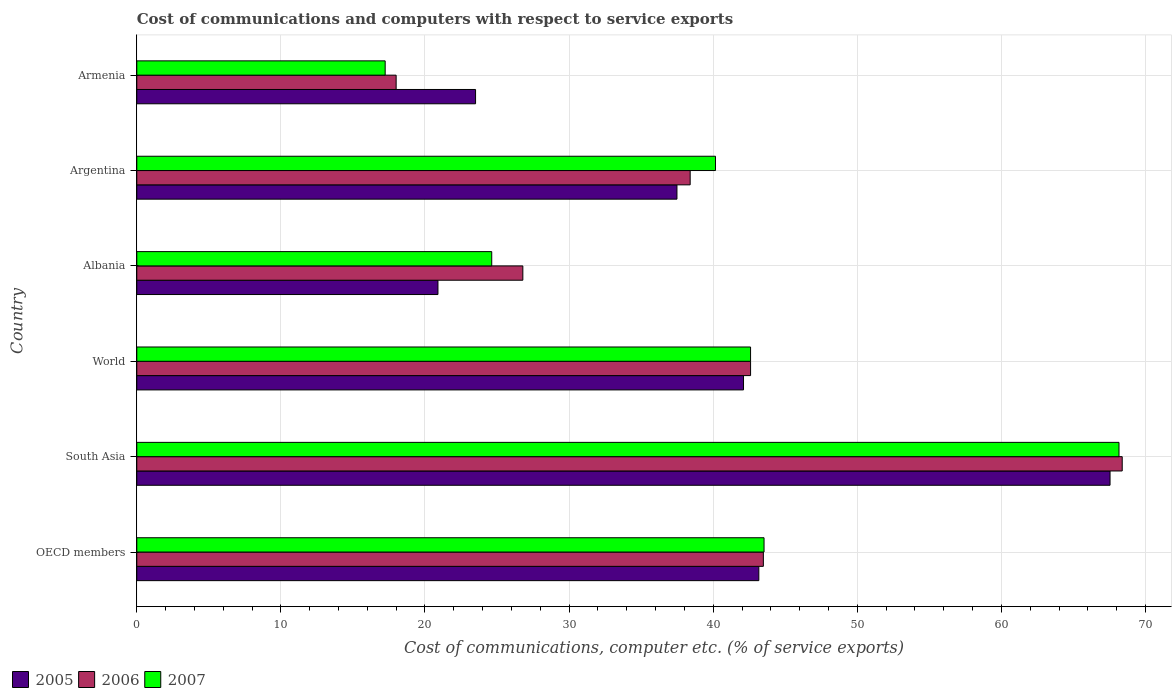How many different coloured bars are there?
Keep it short and to the point. 3. Are the number of bars on each tick of the Y-axis equal?
Ensure brevity in your answer.  Yes. What is the label of the 1st group of bars from the top?
Make the answer very short. Armenia. What is the cost of communications and computers in 2006 in Albania?
Offer a terse response. 26.79. Across all countries, what is the maximum cost of communications and computers in 2006?
Provide a succinct answer. 68.39. Across all countries, what is the minimum cost of communications and computers in 2007?
Ensure brevity in your answer.  17.24. In which country was the cost of communications and computers in 2006 minimum?
Provide a short and direct response. Armenia. What is the total cost of communications and computers in 2006 in the graph?
Your answer should be compact. 237.65. What is the difference between the cost of communications and computers in 2005 in South Asia and that in World?
Make the answer very short. 25.44. What is the difference between the cost of communications and computers in 2005 in South Asia and the cost of communications and computers in 2007 in Armenia?
Offer a very short reply. 50.3. What is the average cost of communications and computers in 2007 per country?
Keep it short and to the point. 39.39. What is the difference between the cost of communications and computers in 2006 and cost of communications and computers in 2005 in Argentina?
Provide a short and direct response. 0.92. In how many countries, is the cost of communications and computers in 2007 greater than 32 %?
Ensure brevity in your answer.  4. What is the ratio of the cost of communications and computers in 2007 in Albania to that in World?
Your answer should be very brief. 0.58. Is the difference between the cost of communications and computers in 2006 in South Asia and World greater than the difference between the cost of communications and computers in 2005 in South Asia and World?
Your answer should be very brief. Yes. What is the difference between the highest and the second highest cost of communications and computers in 2006?
Keep it short and to the point. 24.9. What is the difference between the highest and the lowest cost of communications and computers in 2006?
Offer a terse response. 50.39. In how many countries, is the cost of communications and computers in 2007 greater than the average cost of communications and computers in 2007 taken over all countries?
Give a very brief answer. 4. Is the sum of the cost of communications and computers in 2006 in OECD members and South Asia greater than the maximum cost of communications and computers in 2007 across all countries?
Give a very brief answer. Yes. What does the 1st bar from the bottom in Armenia represents?
Provide a succinct answer. 2005. Are all the bars in the graph horizontal?
Your answer should be very brief. Yes. Are the values on the major ticks of X-axis written in scientific E-notation?
Ensure brevity in your answer.  No. Where does the legend appear in the graph?
Make the answer very short. Bottom left. How many legend labels are there?
Provide a succinct answer. 3. How are the legend labels stacked?
Your answer should be very brief. Horizontal. What is the title of the graph?
Your response must be concise. Cost of communications and computers with respect to service exports. Does "1979" appear as one of the legend labels in the graph?
Your answer should be very brief. No. What is the label or title of the X-axis?
Offer a very short reply. Cost of communications, computer etc. (% of service exports). What is the Cost of communications, computer etc. (% of service exports) in 2005 in OECD members?
Your answer should be compact. 43.17. What is the Cost of communications, computer etc. (% of service exports) in 2006 in OECD members?
Offer a very short reply. 43.48. What is the Cost of communications, computer etc. (% of service exports) in 2007 in OECD members?
Offer a very short reply. 43.53. What is the Cost of communications, computer etc. (% of service exports) of 2005 in South Asia?
Make the answer very short. 67.54. What is the Cost of communications, computer etc. (% of service exports) in 2006 in South Asia?
Ensure brevity in your answer.  68.39. What is the Cost of communications, computer etc. (% of service exports) of 2007 in South Asia?
Your response must be concise. 68.16. What is the Cost of communications, computer etc. (% of service exports) in 2005 in World?
Make the answer very short. 42.1. What is the Cost of communications, computer etc. (% of service exports) of 2006 in World?
Offer a very short reply. 42.59. What is the Cost of communications, computer etc. (% of service exports) of 2007 in World?
Your answer should be very brief. 42.59. What is the Cost of communications, computer etc. (% of service exports) of 2005 in Albania?
Ensure brevity in your answer.  20.9. What is the Cost of communications, computer etc. (% of service exports) of 2006 in Albania?
Offer a very short reply. 26.79. What is the Cost of communications, computer etc. (% of service exports) in 2007 in Albania?
Your answer should be very brief. 24.63. What is the Cost of communications, computer etc. (% of service exports) in 2005 in Argentina?
Make the answer very short. 37.49. What is the Cost of communications, computer etc. (% of service exports) in 2006 in Argentina?
Your response must be concise. 38.4. What is the Cost of communications, computer etc. (% of service exports) of 2007 in Argentina?
Keep it short and to the point. 40.16. What is the Cost of communications, computer etc. (% of service exports) in 2005 in Armenia?
Offer a terse response. 23.51. What is the Cost of communications, computer etc. (% of service exports) in 2006 in Armenia?
Ensure brevity in your answer.  18. What is the Cost of communications, computer etc. (% of service exports) of 2007 in Armenia?
Your answer should be very brief. 17.24. Across all countries, what is the maximum Cost of communications, computer etc. (% of service exports) of 2005?
Give a very brief answer. 67.54. Across all countries, what is the maximum Cost of communications, computer etc. (% of service exports) of 2006?
Ensure brevity in your answer.  68.39. Across all countries, what is the maximum Cost of communications, computer etc. (% of service exports) in 2007?
Offer a very short reply. 68.16. Across all countries, what is the minimum Cost of communications, computer etc. (% of service exports) of 2005?
Give a very brief answer. 20.9. Across all countries, what is the minimum Cost of communications, computer etc. (% of service exports) of 2006?
Offer a very short reply. 18. Across all countries, what is the minimum Cost of communications, computer etc. (% of service exports) in 2007?
Your answer should be compact. 17.24. What is the total Cost of communications, computer etc. (% of service exports) of 2005 in the graph?
Your response must be concise. 234.71. What is the total Cost of communications, computer etc. (% of service exports) in 2006 in the graph?
Ensure brevity in your answer.  237.65. What is the total Cost of communications, computer etc. (% of service exports) of 2007 in the graph?
Your answer should be compact. 236.31. What is the difference between the Cost of communications, computer etc. (% of service exports) in 2005 in OECD members and that in South Asia?
Your answer should be very brief. -24.37. What is the difference between the Cost of communications, computer etc. (% of service exports) of 2006 in OECD members and that in South Asia?
Keep it short and to the point. -24.9. What is the difference between the Cost of communications, computer etc. (% of service exports) in 2007 in OECD members and that in South Asia?
Your answer should be very brief. -24.63. What is the difference between the Cost of communications, computer etc. (% of service exports) of 2005 in OECD members and that in World?
Offer a very short reply. 1.06. What is the difference between the Cost of communications, computer etc. (% of service exports) of 2006 in OECD members and that in World?
Your answer should be compact. 0.89. What is the difference between the Cost of communications, computer etc. (% of service exports) in 2007 in OECD members and that in World?
Provide a succinct answer. 0.94. What is the difference between the Cost of communications, computer etc. (% of service exports) in 2005 in OECD members and that in Albania?
Offer a very short reply. 22.27. What is the difference between the Cost of communications, computer etc. (% of service exports) in 2006 in OECD members and that in Albania?
Ensure brevity in your answer.  16.69. What is the difference between the Cost of communications, computer etc. (% of service exports) of 2007 in OECD members and that in Albania?
Your response must be concise. 18.9. What is the difference between the Cost of communications, computer etc. (% of service exports) of 2005 in OECD members and that in Argentina?
Make the answer very short. 5.68. What is the difference between the Cost of communications, computer etc. (% of service exports) in 2006 in OECD members and that in Argentina?
Your answer should be very brief. 5.08. What is the difference between the Cost of communications, computer etc. (% of service exports) in 2007 in OECD members and that in Argentina?
Offer a very short reply. 3.37. What is the difference between the Cost of communications, computer etc. (% of service exports) of 2005 in OECD members and that in Armenia?
Ensure brevity in your answer.  19.66. What is the difference between the Cost of communications, computer etc. (% of service exports) in 2006 in OECD members and that in Armenia?
Offer a terse response. 25.48. What is the difference between the Cost of communications, computer etc. (% of service exports) of 2007 in OECD members and that in Armenia?
Provide a short and direct response. 26.29. What is the difference between the Cost of communications, computer etc. (% of service exports) of 2005 in South Asia and that in World?
Your response must be concise. 25.44. What is the difference between the Cost of communications, computer etc. (% of service exports) of 2006 in South Asia and that in World?
Provide a succinct answer. 25.79. What is the difference between the Cost of communications, computer etc. (% of service exports) of 2007 in South Asia and that in World?
Your response must be concise. 25.57. What is the difference between the Cost of communications, computer etc. (% of service exports) of 2005 in South Asia and that in Albania?
Offer a very short reply. 46.64. What is the difference between the Cost of communications, computer etc. (% of service exports) of 2006 in South Asia and that in Albania?
Give a very brief answer. 41.59. What is the difference between the Cost of communications, computer etc. (% of service exports) in 2007 in South Asia and that in Albania?
Give a very brief answer. 43.53. What is the difference between the Cost of communications, computer etc. (% of service exports) of 2005 in South Asia and that in Argentina?
Make the answer very short. 30.06. What is the difference between the Cost of communications, computer etc. (% of service exports) of 2006 in South Asia and that in Argentina?
Ensure brevity in your answer.  29.98. What is the difference between the Cost of communications, computer etc. (% of service exports) of 2007 in South Asia and that in Argentina?
Make the answer very short. 28. What is the difference between the Cost of communications, computer etc. (% of service exports) of 2005 in South Asia and that in Armenia?
Your answer should be compact. 44.03. What is the difference between the Cost of communications, computer etc. (% of service exports) of 2006 in South Asia and that in Armenia?
Your answer should be compact. 50.39. What is the difference between the Cost of communications, computer etc. (% of service exports) in 2007 in South Asia and that in Armenia?
Provide a succinct answer. 50.92. What is the difference between the Cost of communications, computer etc. (% of service exports) in 2005 in World and that in Albania?
Your answer should be compact. 21.2. What is the difference between the Cost of communications, computer etc. (% of service exports) in 2006 in World and that in Albania?
Your answer should be compact. 15.8. What is the difference between the Cost of communications, computer etc. (% of service exports) of 2007 in World and that in Albania?
Make the answer very short. 17.96. What is the difference between the Cost of communications, computer etc. (% of service exports) of 2005 in World and that in Argentina?
Your answer should be very brief. 4.62. What is the difference between the Cost of communications, computer etc. (% of service exports) in 2006 in World and that in Argentina?
Make the answer very short. 4.19. What is the difference between the Cost of communications, computer etc. (% of service exports) of 2007 in World and that in Argentina?
Make the answer very short. 2.43. What is the difference between the Cost of communications, computer etc. (% of service exports) of 2005 in World and that in Armenia?
Give a very brief answer. 18.59. What is the difference between the Cost of communications, computer etc. (% of service exports) of 2006 in World and that in Armenia?
Provide a short and direct response. 24.6. What is the difference between the Cost of communications, computer etc. (% of service exports) in 2007 in World and that in Armenia?
Offer a terse response. 25.36. What is the difference between the Cost of communications, computer etc. (% of service exports) of 2005 in Albania and that in Argentina?
Offer a very short reply. -16.59. What is the difference between the Cost of communications, computer etc. (% of service exports) of 2006 in Albania and that in Argentina?
Make the answer very short. -11.61. What is the difference between the Cost of communications, computer etc. (% of service exports) in 2007 in Albania and that in Argentina?
Keep it short and to the point. -15.53. What is the difference between the Cost of communications, computer etc. (% of service exports) in 2005 in Albania and that in Armenia?
Offer a terse response. -2.61. What is the difference between the Cost of communications, computer etc. (% of service exports) in 2006 in Albania and that in Armenia?
Offer a very short reply. 8.79. What is the difference between the Cost of communications, computer etc. (% of service exports) in 2007 in Albania and that in Armenia?
Provide a succinct answer. 7.39. What is the difference between the Cost of communications, computer etc. (% of service exports) of 2005 in Argentina and that in Armenia?
Offer a terse response. 13.98. What is the difference between the Cost of communications, computer etc. (% of service exports) in 2006 in Argentina and that in Armenia?
Your response must be concise. 20.4. What is the difference between the Cost of communications, computer etc. (% of service exports) of 2007 in Argentina and that in Armenia?
Make the answer very short. 22.92. What is the difference between the Cost of communications, computer etc. (% of service exports) of 2005 in OECD members and the Cost of communications, computer etc. (% of service exports) of 2006 in South Asia?
Your response must be concise. -25.22. What is the difference between the Cost of communications, computer etc. (% of service exports) of 2005 in OECD members and the Cost of communications, computer etc. (% of service exports) of 2007 in South Asia?
Provide a succinct answer. -24.99. What is the difference between the Cost of communications, computer etc. (% of service exports) in 2006 in OECD members and the Cost of communications, computer etc. (% of service exports) in 2007 in South Asia?
Your answer should be compact. -24.68. What is the difference between the Cost of communications, computer etc. (% of service exports) in 2005 in OECD members and the Cost of communications, computer etc. (% of service exports) in 2006 in World?
Your response must be concise. 0.57. What is the difference between the Cost of communications, computer etc. (% of service exports) in 2005 in OECD members and the Cost of communications, computer etc. (% of service exports) in 2007 in World?
Provide a short and direct response. 0.57. What is the difference between the Cost of communications, computer etc. (% of service exports) of 2006 in OECD members and the Cost of communications, computer etc. (% of service exports) of 2007 in World?
Your answer should be very brief. 0.89. What is the difference between the Cost of communications, computer etc. (% of service exports) of 2005 in OECD members and the Cost of communications, computer etc. (% of service exports) of 2006 in Albania?
Your answer should be compact. 16.38. What is the difference between the Cost of communications, computer etc. (% of service exports) in 2005 in OECD members and the Cost of communications, computer etc. (% of service exports) in 2007 in Albania?
Your answer should be very brief. 18.53. What is the difference between the Cost of communications, computer etc. (% of service exports) of 2006 in OECD members and the Cost of communications, computer etc. (% of service exports) of 2007 in Albania?
Keep it short and to the point. 18.85. What is the difference between the Cost of communications, computer etc. (% of service exports) in 2005 in OECD members and the Cost of communications, computer etc. (% of service exports) in 2006 in Argentina?
Your response must be concise. 4.76. What is the difference between the Cost of communications, computer etc. (% of service exports) of 2005 in OECD members and the Cost of communications, computer etc. (% of service exports) of 2007 in Argentina?
Your response must be concise. 3.01. What is the difference between the Cost of communications, computer etc. (% of service exports) of 2006 in OECD members and the Cost of communications, computer etc. (% of service exports) of 2007 in Argentina?
Your answer should be compact. 3.32. What is the difference between the Cost of communications, computer etc. (% of service exports) in 2005 in OECD members and the Cost of communications, computer etc. (% of service exports) in 2006 in Armenia?
Provide a short and direct response. 25.17. What is the difference between the Cost of communications, computer etc. (% of service exports) in 2005 in OECD members and the Cost of communications, computer etc. (% of service exports) in 2007 in Armenia?
Your answer should be very brief. 25.93. What is the difference between the Cost of communications, computer etc. (% of service exports) in 2006 in OECD members and the Cost of communications, computer etc. (% of service exports) in 2007 in Armenia?
Provide a succinct answer. 26.24. What is the difference between the Cost of communications, computer etc. (% of service exports) of 2005 in South Asia and the Cost of communications, computer etc. (% of service exports) of 2006 in World?
Make the answer very short. 24.95. What is the difference between the Cost of communications, computer etc. (% of service exports) of 2005 in South Asia and the Cost of communications, computer etc. (% of service exports) of 2007 in World?
Provide a short and direct response. 24.95. What is the difference between the Cost of communications, computer etc. (% of service exports) of 2006 in South Asia and the Cost of communications, computer etc. (% of service exports) of 2007 in World?
Provide a succinct answer. 25.79. What is the difference between the Cost of communications, computer etc. (% of service exports) in 2005 in South Asia and the Cost of communications, computer etc. (% of service exports) in 2006 in Albania?
Keep it short and to the point. 40.75. What is the difference between the Cost of communications, computer etc. (% of service exports) of 2005 in South Asia and the Cost of communications, computer etc. (% of service exports) of 2007 in Albania?
Your answer should be compact. 42.91. What is the difference between the Cost of communications, computer etc. (% of service exports) in 2006 in South Asia and the Cost of communications, computer etc. (% of service exports) in 2007 in Albania?
Provide a short and direct response. 43.75. What is the difference between the Cost of communications, computer etc. (% of service exports) in 2005 in South Asia and the Cost of communications, computer etc. (% of service exports) in 2006 in Argentina?
Your answer should be very brief. 29.14. What is the difference between the Cost of communications, computer etc. (% of service exports) in 2005 in South Asia and the Cost of communications, computer etc. (% of service exports) in 2007 in Argentina?
Ensure brevity in your answer.  27.38. What is the difference between the Cost of communications, computer etc. (% of service exports) in 2006 in South Asia and the Cost of communications, computer etc. (% of service exports) in 2007 in Argentina?
Give a very brief answer. 28.23. What is the difference between the Cost of communications, computer etc. (% of service exports) in 2005 in South Asia and the Cost of communications, computer etc. (% of service exports) in 2006 in Armenia?
Your response must be concise. 49.54. What is the difference between the Cost of communications, computer etc. (% of service exports) of 2005 in South Asia and the Cost of communications, computer etc. (% of service exports) of 2007 in Armenia?
Make the answer very short. 50.3. What is the difference between the Cost of communications, computer etc. (% of service exports) in 2006 in South Asia and the Cost of communications, computer etc. (% of service exports) in 2007 in Armenia?
Provide a short and direct response. 51.15. What is the difference between the Cost of communications, computer etc. (% of service exports) of 2005 in World and the Cost of communications, computer etc. (% of service exports) of 2006 in Albania?
Give a very brief answer. 15.31. What is the difference between the Cost of communications, computer etc. (% of service exports) of 2005 in World and the Cost of communications, computer etc. (% of service exports) of 2007 in Albania?
Your answer should be very brief. 17.47. What is the difference between the Cost of communications, computer etc. (% of service exports) of 2006 in World and the Cost of communications, computer etc. (% of service exports) of 2007 in Albania?
Keep it short and to the point. 17.96. What is the difference between the Cost of communications, computer etc. (% of service exports) in 2005 in World and the Cost of communications, computer etc. (% of service exports) in 2006 in Argentina?
Keep it short and to the point. 3.7. What is the difference between the Cost of communications, computer etc. (% of service exports) of 2005 in World and the Cost of communications, computer etc. (% of service exports) of 2007 in Argentina?
Make the answer very short. 1.95. What is the difference between the Cost of communications, computer etc. (% of service exports) of 2006 in World and the Cost of communications, computer etc. (% of service exports) of 2007 in Argentina?
Your response must be concise. 2.44. What is the difference between the Cost of communications, computer etc. (% of service exports) in 2005 in World and the Cost of communications, computer etc. (% of service exports) in 2006 in Armenia?
Keep it short and to the point. 24.11. What is the difference between the Cost of communications, computer etc. (% of service exports) of 2005 in World and the Cost of communications, computer etc. (% of service exports) of 2007 in Armenia?
Your answer should be compact. 24.87. What is the difference between the Cost of communications, computer etc. (% of service exports) of 2006 in World and the Cost of communications, computer etc. (% of service exports) of 2007 in Armenia?
Your answer should be very brief. 25.36. What is the difference between the Cost of communications, computer etc. (% of service exports) in 2005 in Albania and the Cost of communications, computer etc. (% of service exports) in 2006 in Argentina?
Provide a short and direct response. -17.5. What is the difference between the Cost of communications, computer etc. (% of service exports) of 2005 in Albania and the Cost of communications, computer etc. (% of service exports) of 2007 in Argentina?
Make the answer very short. -19.26. What is the difference between the Cost of communications, computer etc. (% of service exports) of 2006 in Albania and the Cost of communications, computer etc. (% of service exports) of 2007 in Argentina?
Your answer should be compact. -13.37. What is the difference between the Cost of communications, computer etc. (% of service exports) of 2005 in Albania and the Cost of communications, computer etc. (% of service exports) of 2006 in Armenia?
Give a very brief answer. 2.9. What is the difference between the Cost of communications, computer etc. (% of service exports) of 2005 in Albania and the Cost of communications, computer etc. (% of service exports) of 2007 in Armenia?
Give a very brief answer. 3.66. What is the difference between the Cost of communications, computer etc. (% of service exports) in 2006 in Albania and the Cost of communications, computer etc. (% of service exports) in 2007 in Armenia?
Offer a terse response. 9.55. What is the difference between the Cost of communications, computer etc. (% of service exports) of 2005 in Argentina and the Cost of communications, computer etc. (% of service exports) of 2006 in Armenia?
Your answer should be very brief. 19.49. What is the difference between the Cost of communications, computer etc. (% of service exports) in 2005 in Argentina and the Cost of communications, computer etc. (% of service exports) in 2007 in Armenia?
Your response must be concise. 20.25. What is the difference between the Cost of communications, computer etc. (% of service exports) in 2006 in Argentina and the Cost of communications, computer etc. (% of service exports) in 2007 in Armenia?
Provide a short and direct response. 21.17. What is the average Cost of communications, computer etc. (% of service exports) of 2005 per country?
Provide a short and direct response. 39.12. What is the average Cost of communications, computer etc. (% of service exports) in 2006 per country?
Ensure brevity in your answer.  39.61. What is the average Cost of communications, computer etc. (% of service exports) of 2007 per country?
Your answer should be compact. 39.38. What is the difference between the Cost of communications, computer etc. (% of service exports) of 2005 and Cost of communications, computer etc. (% of service exports) of 2006 in OECD members?
Keep it short and to the point. -0.32. What is the difference between the Cost of communications, computer etc. (% of service exports) in 2005 and Cost of communications, computer etc. (% of service exports) in 2007 in OECD members?
Give a very brief answer. -0.36. What is the difference between the Cost of communications, computer etc. (% of service exports) in 2006 and Cost of communications, computer etc. (% of service exports) in 2007 in OECD members?
Provide a short and direct response. -0.05. What is the difference between the Cost of communications, computer etc. (% of service exports) of 2005 and Cost of communications, computer etc. (% of service exports) of 2006 in South Asia?
Give a very brief answer. -0.84. What is the difference between the Cost of communications, computer etc. (% of service exports) in 2005 and Cost of communications, computer etc. (% of service exports) in 2007 in South Asia?
Your answer should be compact. -0.62. What is the difference between the Cost of communications, computer etc. (% of service exports) in 2006 and Cost of communications, computer etc. (% of service exports) in 2007 in South Asia?
Keep it short and to the point. 0.22. What is the difference between the Cost of communications, computer etc. (% of service exports) of 2005 and Cost of communications, computer etc. (% of service exports) of 2006 in World?
Make the answer very short. -0.49. What is the difference between the Cost of communications, computer etc. (% of service exports) in 2005 and Cost of communications, computer etc. (% of service exports) in 2007 in World?
Your answer should be very brief. -0.49. What is the difference between the Cost of communications, computer etc. (% of service exports) of 2006 and Cost of communications, computer etc. (% of service exports) of 2007 in World?
Your response must be concise. 0. What is the difference between the Cost of communications, computer etc. (% of service exports) of 2005 and Cost of communications, computer etc. (% of service exports) of 2006 in Albania?
Offer a very short reply. -5.89. What is the difference between the Cost of communications, computer etc. (% of service exports) of 2005 and Cost of communications, computer etc. (% of service exports) of 2007 in Albania?
Offer a very short reply. -3.73. What is the difference between the Cost of communications, computer etc. (% of service exports) of 2006 and Cost of communications, computer etc. (% of service exports) of 2007 in Albania?
Ensure brevity in your answer.  2.16. What is the difference between the Cost of communications, computer etc. (% of service exports) in 2005 and Cost of communications, computer etc. (% of service exports) in 2006 in Argentina?
Your response must be concise. -0.92. What is the difference between the Cost of communications, computer etc. (% of service exports) in 2005 and Cost of communications, computer etc. (% of service exports) in 2007 in Argentina?
Your answer should be compact. -2.67. What is the difference between the Cost of communications, computer etc. (% of service exports) of 2006 and Cost of communications, computer etc. (% of service exports) of 2007 in Argentina?
Your response must be concise. -1.76. What is the difference between the Cost of communications, computer etc. (% of service exports) in 2005 and Cost of communications, computer etc. (% of service exports) in 2006 in Armenia?
Provide a short and direct response. 5.51. What is the difference between the Cost of communications, computer etc. (% of service exports) in 2005 and Cost of communications, computer etc. (% of service exports) in 2007 in Armenia?
Provide a short and direct response. 6.27. What is the difference between the Cost of communications, computer etc. (% of service exports) of 2006 and Cost of communications, computer etc. (% of service exports) of 2007 in Armenia?
Your response must be concise. 0.76. What is the ratio of the Cost of communications, computer etc. (% of service exports) in 2005 in OECD members to that in South Asia?
Your response must be concise. 0.64. What is the ratio of the Cost of communications, computer etc. (% of service exports) of 2006 in OECD members to that in South Asia?
Offer a terse response. 0.64. What is the ratio of the Cost of communications, computer etc. (% of service exports) of 2007 in OECD members to that in South Asia?
Provide a short and direct response. 0.64. What is the ratio of the Cost of communications, computer etc. (% of service exports) of 2005 in OECD members to that in World?
Offer a terse response. 1.03. What is the ratio of the Cost of communications, computer etc. (% of service exports) of 2006 in OECD members to that in World?
Provide a short and direct response. 1.02. What is the ratio of the Cost of communications, computer etc. (% of service exports) in 2007 in OECD members to that in World?
Your answer should be compact. 1.02. What is the ratio of the Cost of communications, computer etc. (% of service exports) in 2005 in OECD members to that in Albania?
Your answer should be very brief. 2.07. What is the ratio of the Cost of communications, computer etc. (% of service exports) of 2006 in OECD members to that in Albania?
Offer a terse response. 1.62. What is the ratio of the Cost of communications, computer etc. (% of service exports) of 2007 in OECD members to that in Albania?
Provide a succinct answer. 1.77. What is the ratio of the Cost of communications, computer etc. (% of service exports) in 2005 in OECD members to that in Argentina?
Make the answer very short. 1.15. What is the ratio of the Cost of communications, computer etc. (% of service exports) of 2006 in OECD members to that in Argentina?
Your answer should be compact. 1.13. What is the ratio of the Cost of communications, computer etc. (% of service exports) of 2007 in OECD members to that in Argentina?
Ensure brevity in your answer.  1.08. What is the ratio of the Cost of communications, computer etc. (% of service exports) of 2005 in OECD members to that in Armenia?
Give a very brief answer. 1.84. What is the ratio of the Cost of communications, computer etc. (% of service exports) of 2006 in OECD members to that in Armenia?
Your answer should be very brief. 2.42. What is the ratio of the Cost of communications, computer etc. (% of service exports) in 2007 in OECD members to that in Armenia?
Offer a terse response. 2.53. What is the ratio of the Cost of communications, computer etc. (% of service exports) in 2005 in South Asia to that in World?
Give a very brief answer. 1.6. What is the ratio of the Cost of communications, computer etc. (% of service exports) of 2006 in South Asia to that in World?
Keep it short and to the point. 1.61. What is the ratio of the Cost of communications, computer etc. (% of service exports) in 2007 in South Asia to that in World?
Your response must be concise. 1.6. What is the ratio of the Cost of communications, computer etc. (% of service exports) in 2005 in South Asia to that in Albania?
Your answer should be compact. 3.23. What is the ratio of the Cost of communications, computer etc. (% of service exports) of 2006 in South Asia to that in Albania?
Your answer should be very brief. 2.55. What is the ratio of the Cost of communications, computer etc. (% of service exports) of 2007 in South Asia to that in Albania?
Provide a succinct answer. 2.77. What is the ratio of the Cost of communications, computer etc. (% of service exports) of 2005 in South Asia to that in Argentina?
Keep it short and to the point. 1.8. What is the ratio of the Cost of communications, computer etc. (% of service exports) in 2006 in South Asia to that in Argentina?
Your answer should be compact. 1.78. What is the ratio of the Cost of communications, computer etc. (% of service exports) in 2007 in South Asia to that in Argentina?
Ensure brevity in your answer.  1.7. What is the ratio of the Cost of communications, computer etc. (% of service exports) in 2005 in South Asia to that in Armenia?
Offer a very short reply. 2.87. What is the ratio of the Cost of communications, computer etc. (% of service exports) in 2006 in South Asia to that in Armenia?
Offer a very short reply. 3.8. What is the ratio of the Cost of communications, computer etc. (% of service exports) in 2007 in South Asia to that in Armenia?
Offer a very short reply. 3.95. What is the ratio of the Cost of communications, computer etc. (% of service exports) of 2005 in World to that in Albania?
Offer a very short reply. 2.01. What is the ratio of the Cost of communications, computer etc. (% of service exports) of 2006 in World to that in Albania?
Your answer should be compact. 1.59. What is the ratio of the Cost of communications, computer etc. (% of service exports) of 2007 in World to that in Albania?
Your answer should be compact. 1.73. What is the ratio of the Cost of communications, computer etc. (% of service exports) of 2005 in World to that in Argentina?
Offer a very short reply. 1.12. What is the ratio of the Cost of communications, computer etc. (% of service exports) of 2006 in World to that in Argentina?
Provide a succinct answer. 1.11. What is the ratio of the Cost of communications, computer etc. (% of service exports) in 2007 in World to that in Argentina?
Keep it short and to the point. 1.06. What is the ratio of the Cost of communications, computer etc. (% of service exports) of 2005 in World to that in Armenia?
Keep it short and to the point. 1.79. What is the ratio of the Cost of communications, computer etc. (% of service exports) in 2006 in World to that in Armenia?
Provide a succinct answer. 2.37. What is the ratio of the Cost of communications, computer etc. (% of service exports) in 2007 in World to that in Armenia?
Make the answer very short. 2.47. What is the ratio of the Cost of communications, computer etc. (% of service exports) of 2005 in Albania to that in Argentina?
Provide a succinct answer. 0.56. What is the ratio of the Cost of communications, computer etc. (% of service exports) of 2006 in Albania to that in Argentina?
Your response must be concise. 0.7. What is the ratio of the Cost of communications, computer etc. (% of service exports) of 2007 in Albania to that in Argentina?
Offer a very short reply. 0.61. What is the ratio of the Cost of communications, computer etc. (% of service exports) in 2005 in Albania to that in Armenia?
Your response must be concise. 0.89. What is the ratio of the Cost of communications, computer etc. (% of service exports) of 2006 in Albania to that in Armenia?
Your answer should be compact. 1.49. What is the ratio of the Cost of communications, computer etc. (% of service exports) of 2007 in Albania to that in Armenia?
Make the answer very short. 1.43. What is the ratio of the Cost of communications, computer etc. (% of service exports) in 2005 in Argentina to that in Armenia?
Give a very brief answer. 1.59. What is the ratio of the Cost of communications, computer etc. (% of service exports) in 2006 in Argentina to that in Armenia?
Your answer should be very brief. 2.13. What is the ratio of the Cost of communications, computer etc. (% of service exports) of 2007 in Argentina to that in Armenia?
Offer a terse response. 2.33. What is the difference between the highest and the second highest Cost of communications, computer etc. (% of service exports) of 2005?
Your answer should be compact. 24.37. What is the difference between the highest and the second highest Cost of communications, computer etc. (% of service exports) in 2006?
Provide a short and direct response. 24.9. What is the difference between the highest and the second highest Cost of communications, computer etc. (% of service exports) in 2007?
Your answer should be compact. 24.63. What is the difference between the highest and the lowest Cost of communications, computer etc. (% of service exports) in 2005?
Give a very brief answer. 46.64. What is the difference between the highest and the lowest Cost of communications, computer etc. (% of service exports) in 2006?
Ensure brevity in your answer.  50.39. What is the difference between the highest and the lowest Cost of communications, computer etc. (% of service exports) in 2007?
Offer a very short reply. 50.92. 